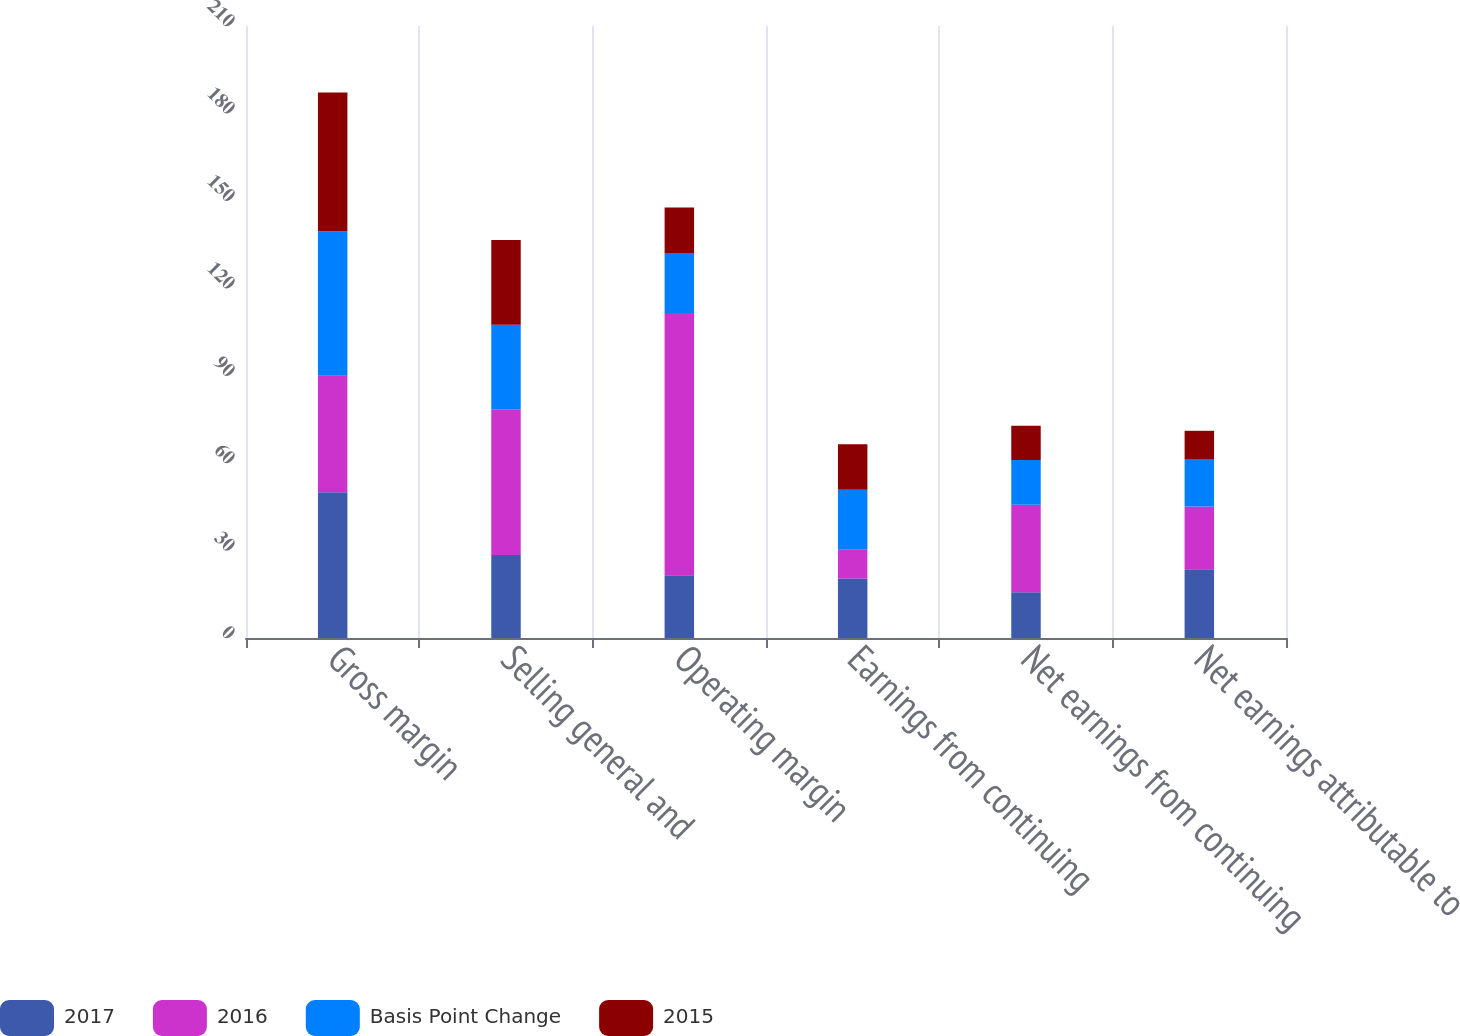Convert chart. <chart><loc_0><loc_0><loc_500><loc_500><stacked_bar_chart><ecel><fcel>Gross margin<fcel>Selling general and<fcel>Operating margin<fcel>Earnings from continuing<fcel>Net earnings from continuing<fcel>Net earnings attributable to<nl><fcel>2017<fcel>50<fcel>28.5<fcel>21.5<fcel>20.4<fcel>15.7<fcel>23.6<nl><fcel>2016<fcel>40<fcel>50<fcel>90<fcel>10<fcel>30<fcel>21.5<nl><fcel>Basis Point Change<fcel>49.6<fcel>29<fcel>20.6<fcel>20.5<fcel>15.4<fcel>16.1<nl><fcel>2015<fcel>47.6<fcel>29.1<fcel>15.6<fcel>15.6<fcel>11.7<fcel>9.9<nl></chart> 